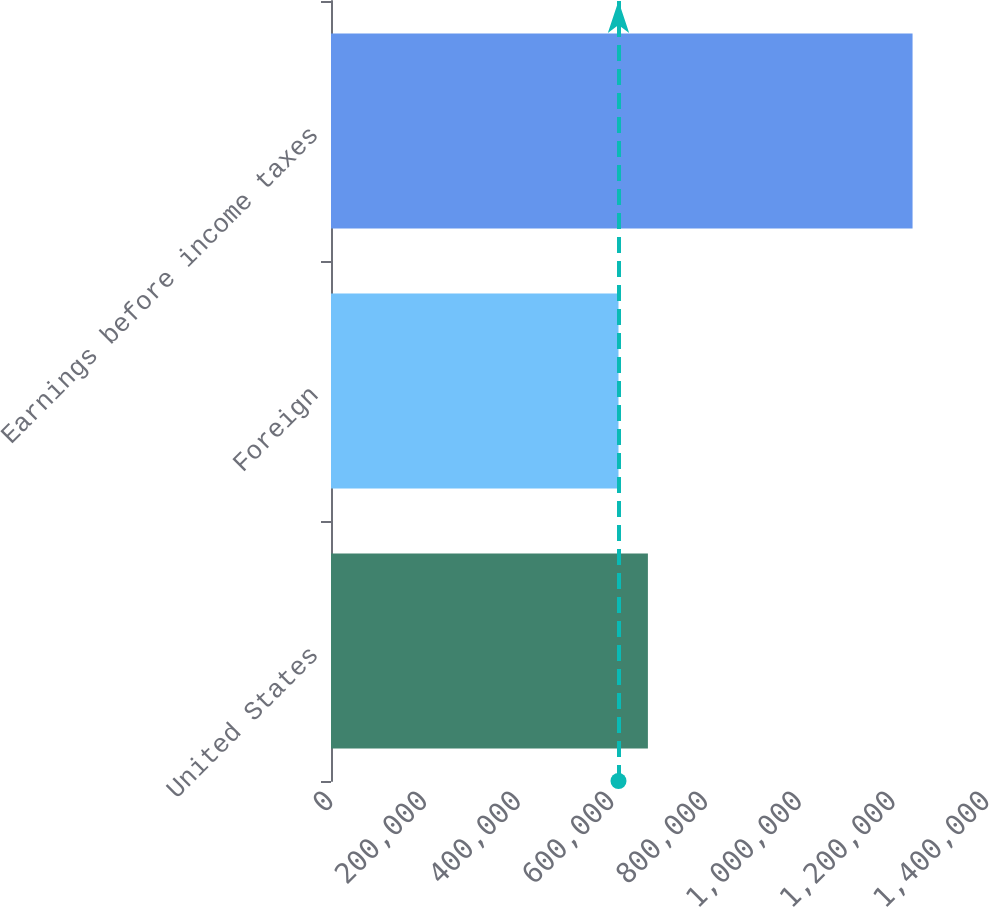<chart> <loc_0><loc_0><loc_500><loc_500><bar_chart><fcel>United States<fcel>Foreign<fcel>Earnings before income taxes<nl><fcel>676315<fcel>613558<fcel>1.24112e+06<nl></chart> 